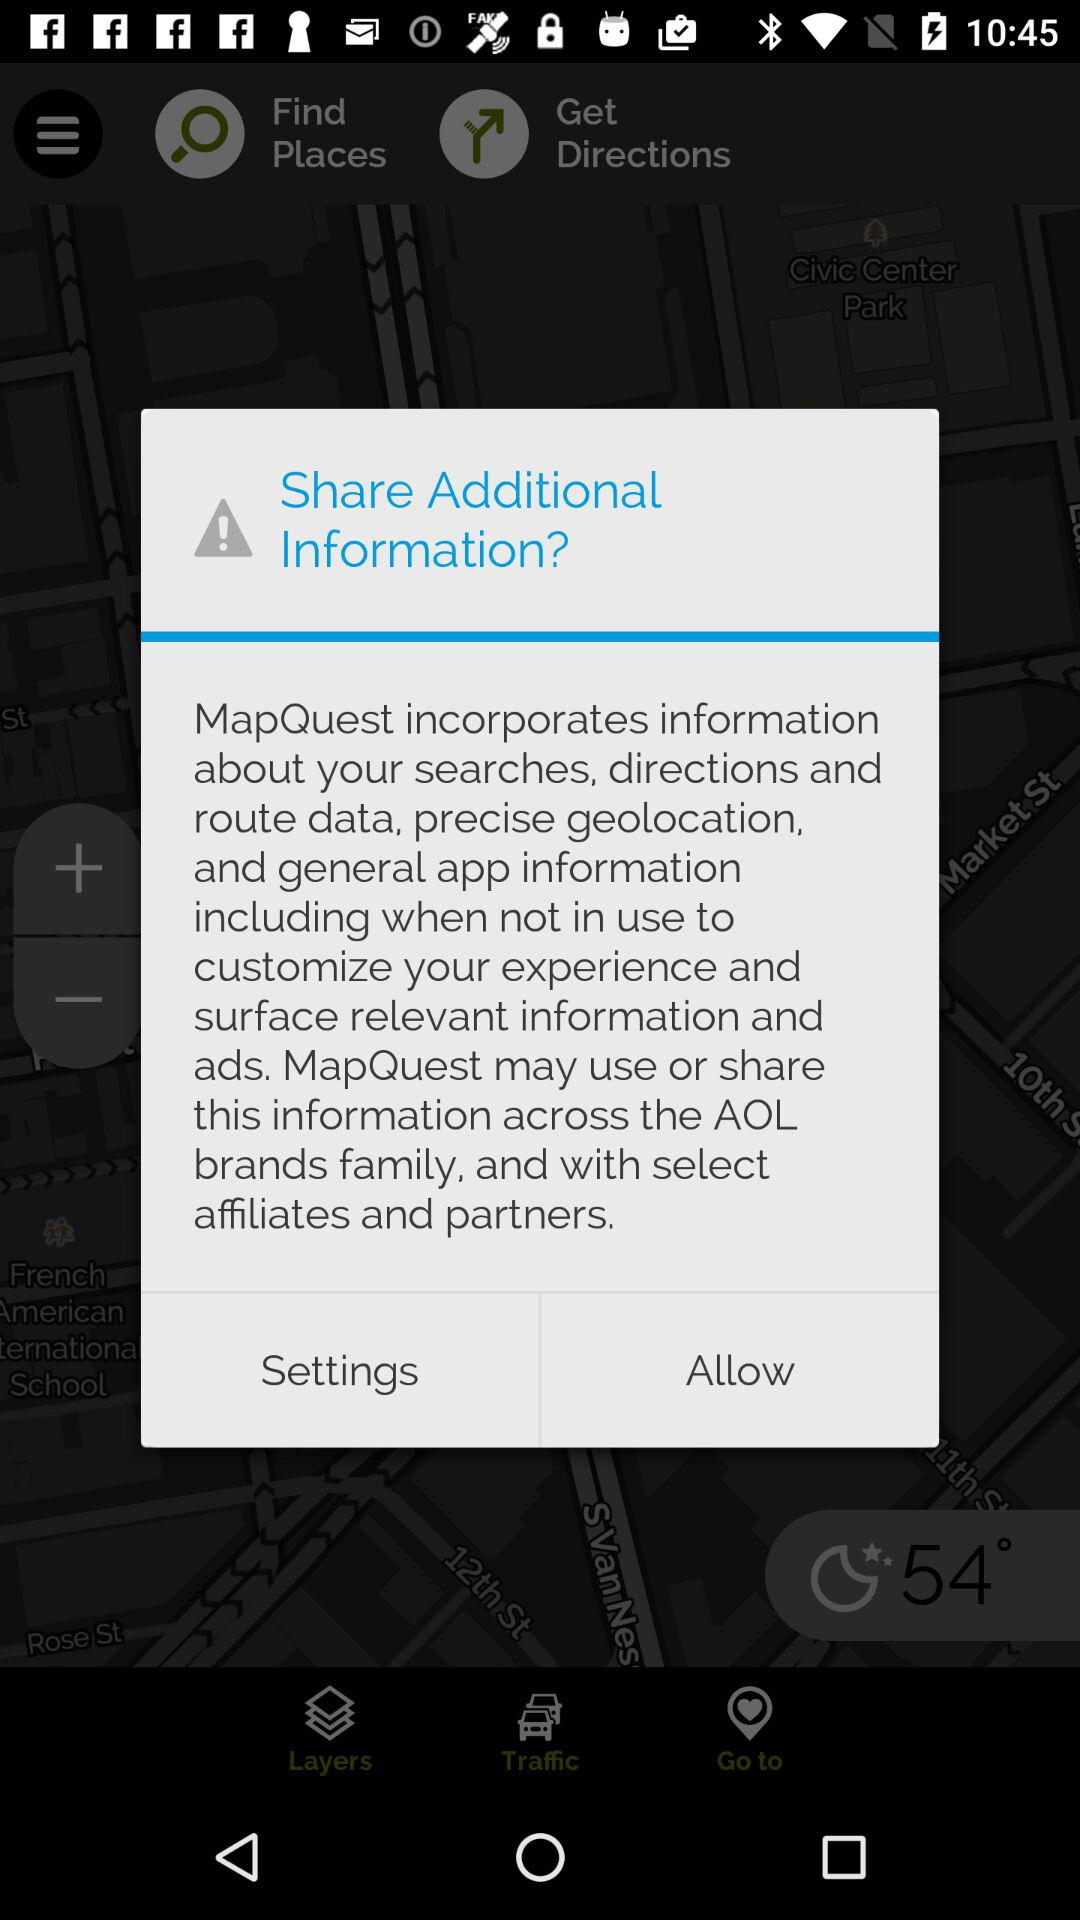What is the temperature? The temperature is 54°. 